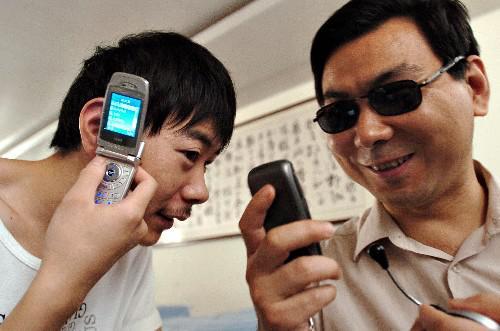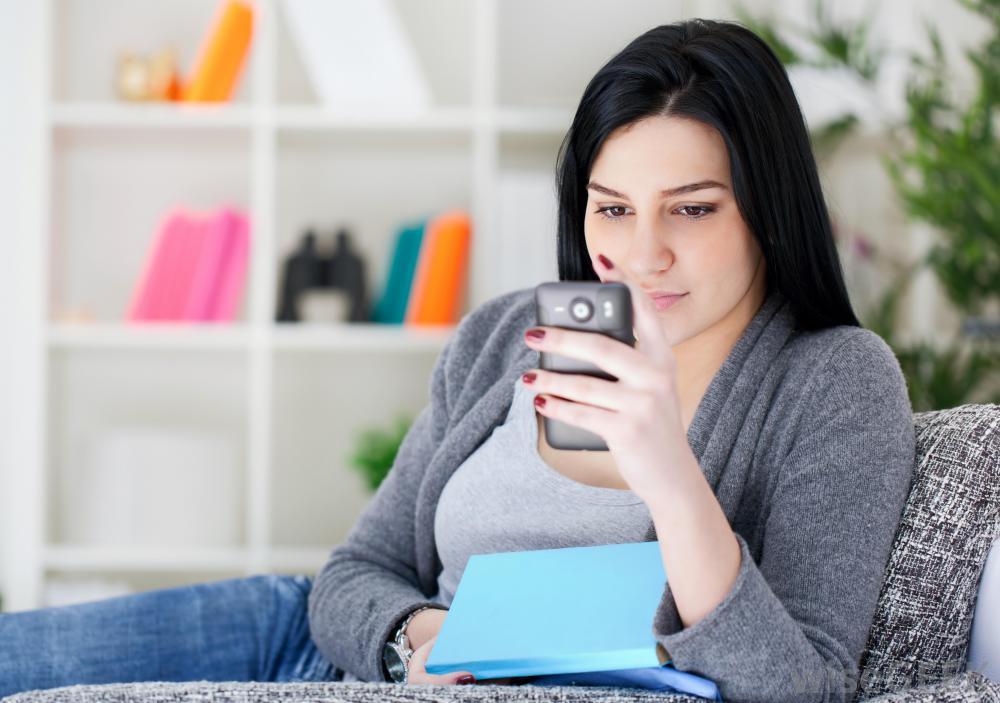The first image is the image on the left, the second image is the image on the right. Examine the images to the left and right. Is the description "Only one person is holding a phone to their ear." accurate? Answer yes or no. Yes. The first image is the image on the left, the second image is the image on the right. Evaluate the accuracy of this statement regarding the images: "In the image to the left, a person is holding a phone; the phone is not up to anyone's ear.". Is it true? Answer yes or no. No. 